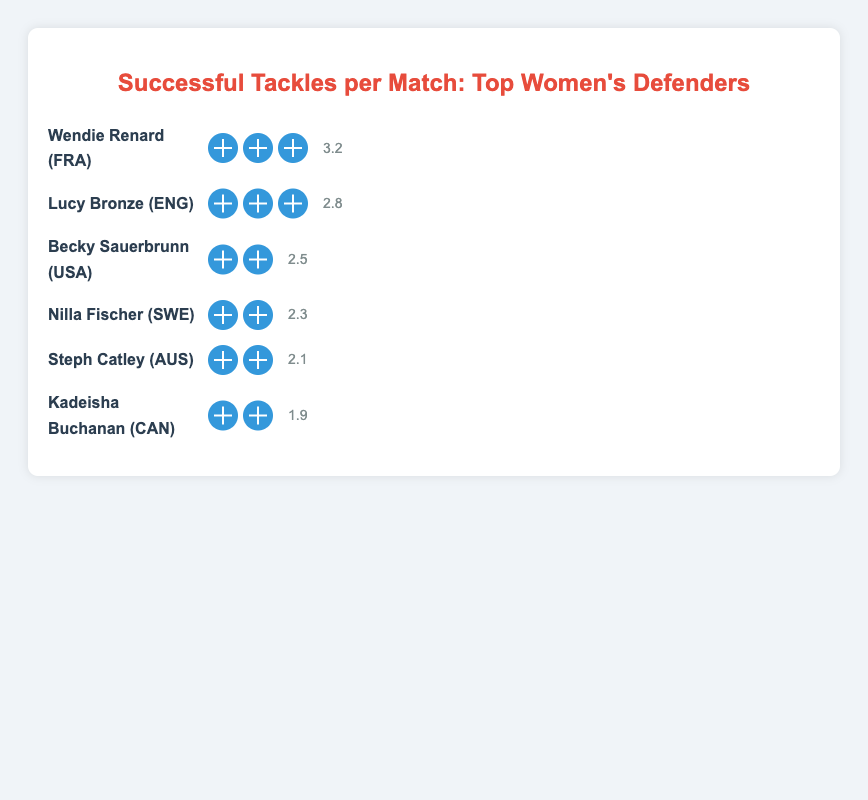Who has the highest number of successful tackles per match? The visualization shows the names of defenders along with their respective figures for tackles per match. Wendie Renard has the highest number, represented as 3 football icons and a label of 3.2 tackles per match.
Answer: Wendie Renard How many defenders have exactly 3 football icons representing their tackles per match? The plot indicates the number of football icons next to each defender's name. Wendie Renard and Lucy Bronze both have 3 football icons.
Answer: 2 Compare the tackles per match between Becky Sauerbrunn and Nilla Fischer. Who has more? The plot shows Becky Sauerbrunn with 2.5 tackles per match and Nilla Fischer with 2.3. Comparing these figures, Becky Sauerbrunn has more tackles per match.
Answer: Becky Sauerbrunn What is the total number of successful tackles per match combined for all the listed defenders? Summing the tackles per match: 3.2 + 2.8 + 2.5 + 2.3 + 2.1 + 1.9 results in a total of 14.8.
Answer: 14.8 Which defender from USA is mentioned and what's her average tackles per match? The plot lists Becky Sauerbrunn as the defender from the USA with an average of 2.5 tackles per match.
Answer: Becky Sauerbrunn, 2.5 Who are the defenders with fewer than 2.5 tackles per match, and how many such defenders are there? The plot shows Nilla Fischer (2.3), Steph Catley (2.1), and Kadeisha Buchanan (1.9), all with fewer than 2.5 tackles per match, making a total of 3 defenders.
Answer: Nilla Fischer, Steph Catley, Kadeisha Buchanan; 3 Which two defenders have the closest number of tackles per match, and what are those numbers? Comparing the values, Nilla Fischer (2.3) and Steph Catley (2.1) have the closest numbers, with a difference of only 0.2 tackles per match.
Answer: Nilla Fischer (2.3), Steph Catley (2.1) What is the average number of successful tackles per match among the top six defenders? Summing the tackles per match (3.2 + 2.8 + 2.5 + 2.3 + 2.1 + 1.9) gives 14.8, and dividing by 6 (since there are six defenders) results in an average of 2.47.
Answer: 2.47 